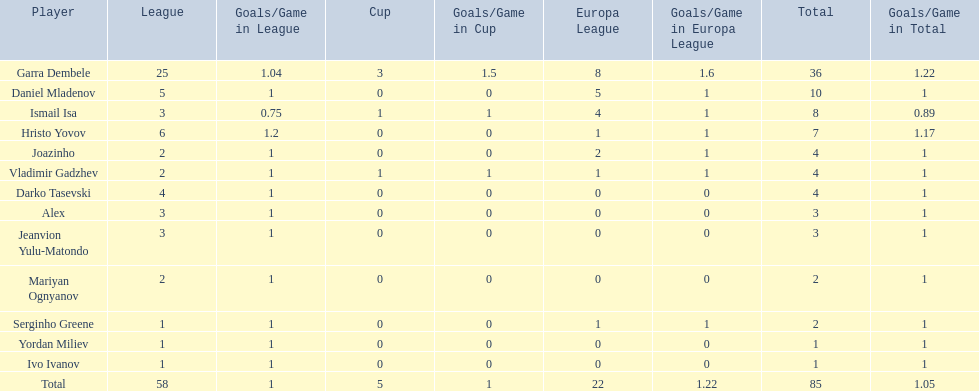What is the difference between vladimir gadzhev and yordan miliev's scores? 3. 